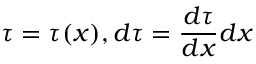Convert formula to latex. <formula><loc_0><loc_0><loc_500><loc_500>\tau = \tau ( x ) , d \tau = \frac { d \tau } { d x } d x</formula> 